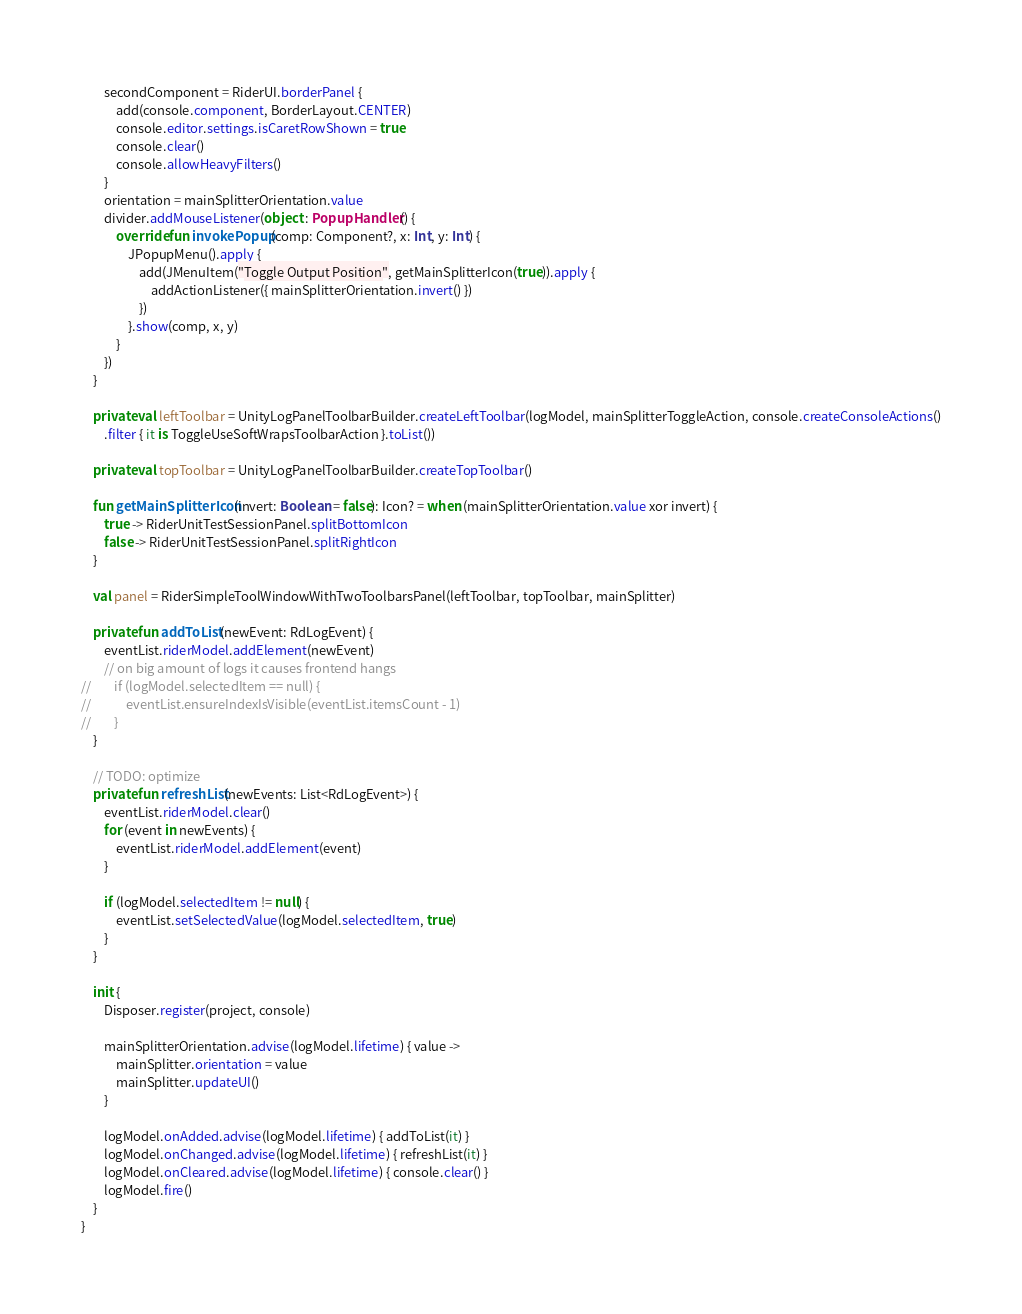<code> <loc_0><loc_0><loc_500><loc_500><_Kotlin_>        secondComponent = RiderUI.borderPanel {
            add(console.component, BorderLayout.CENTER)
            console.editor.settings.isCaretRowShown = true
            console.clear()
            console.allowHeavyFilters()
        }
        orientation = mainSplitterOrientation.value
        divider.addMouseListener(object : PopupHandler() {
            override fun invokePopup(comp: Component?, x: Int, y: Int) {
                JPopupMenu().apply {
                    add(JMenuItem("Toggle Output Position", getMainSplitterIcon(true)).apply {
                        addActionListener({ mainSplitterOrientation.invert() })
                    })
                }.show(comp, x, y)
            }
        })
    }

    private val leftToolbar = UnityLogPanelToolbarBuilder.createLeftToolbar(logModel, mainSplitterToggleAction, console.createConsoleActions()
        .filter { it is ToggleUseSoftWrapsToolbarAction }.toList())

    private val topToolbar = UnityLogPanelToolbarBuilder.createTopToolbar()

    fun getMainSplitterIcon(invert: Boolean = false): Icon? = when (mainSplitterOrientation.value xor invert) {
        true -> RiderUnitTestSessionPanel.splitBottomIcon
        false -> RiderUnitTestSessionPanel.splitRightIcon
    }

    val panel = RiderSimpleToolWindowWithTwoToolbarsPanel(leftToolbar, topToolbar, mainSplitter)

    private fun addToList(newEvent: RdLogEvent) {
        eventList.riderModel.addElement(newEvent)
        // on big amount of logs it causes frontend hangs
//        if (logModel.selectedItem == null) {
//            eventList.ensureIndexIsVisible(eventList.itemsCount - 1)
//        }
    }

    // TODO: optimize
    private fun refreshList(newEvents: List<RdLogEvent>) {
        eventList.riderModel.clear()
        for (event in newEvents) {
            eventList.riderModel.addElement(event)
        }

        if (logModel.selectedItem != null) {
            eventList.setSelectedValue(logModel.selectedItem, true)
        }
    }

    init {
        Disposer.register(project, console)

        mainSplitterOrientation.advise(logModel.lifetime) { value ->
            mainSplitter.orientation = value
            mainSplitter.updateUI()
        }

        logModel.onAdded.advise(logModel.lifetime) { addToList(it) }
        logModel.onChanged.advise(logModel.lifetime) { refreshList(it) }
        logModel.onCleared.advise(logModel.lifetime) { console.clear() }
        logModel.fire()
    }
}</code> 